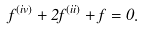Convert formula to latex. <formula><loc_0><loc_0><loc_500><loc_500>f ^ { ( i v ) } + 2 f ^ { ( i i ) } + f = 0 .</formula> 